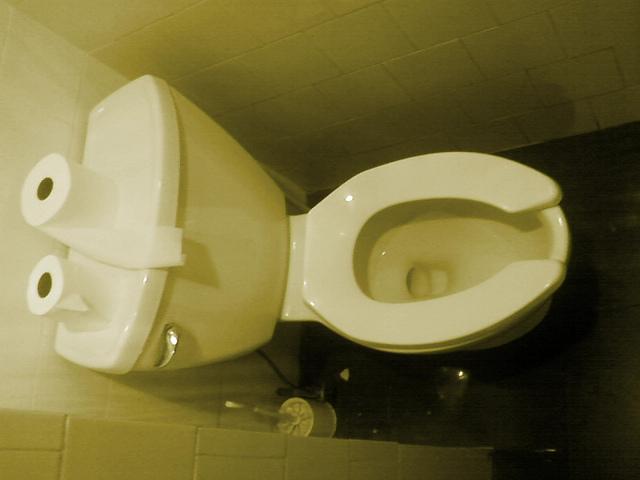Will someone reach in with their bare hands to clean it?
Quick response, please. Yes. Is there a toilet brush?
Keep it brief. Yes. What will pulling the lever do?
Quick response, please. Flush. Is there toilet paper visible?
Write a very short answer. Yes. Where are the rolls of paper?
Quick response, please. Back of toilet. What color is the toilet?
Quick response, please. White. 